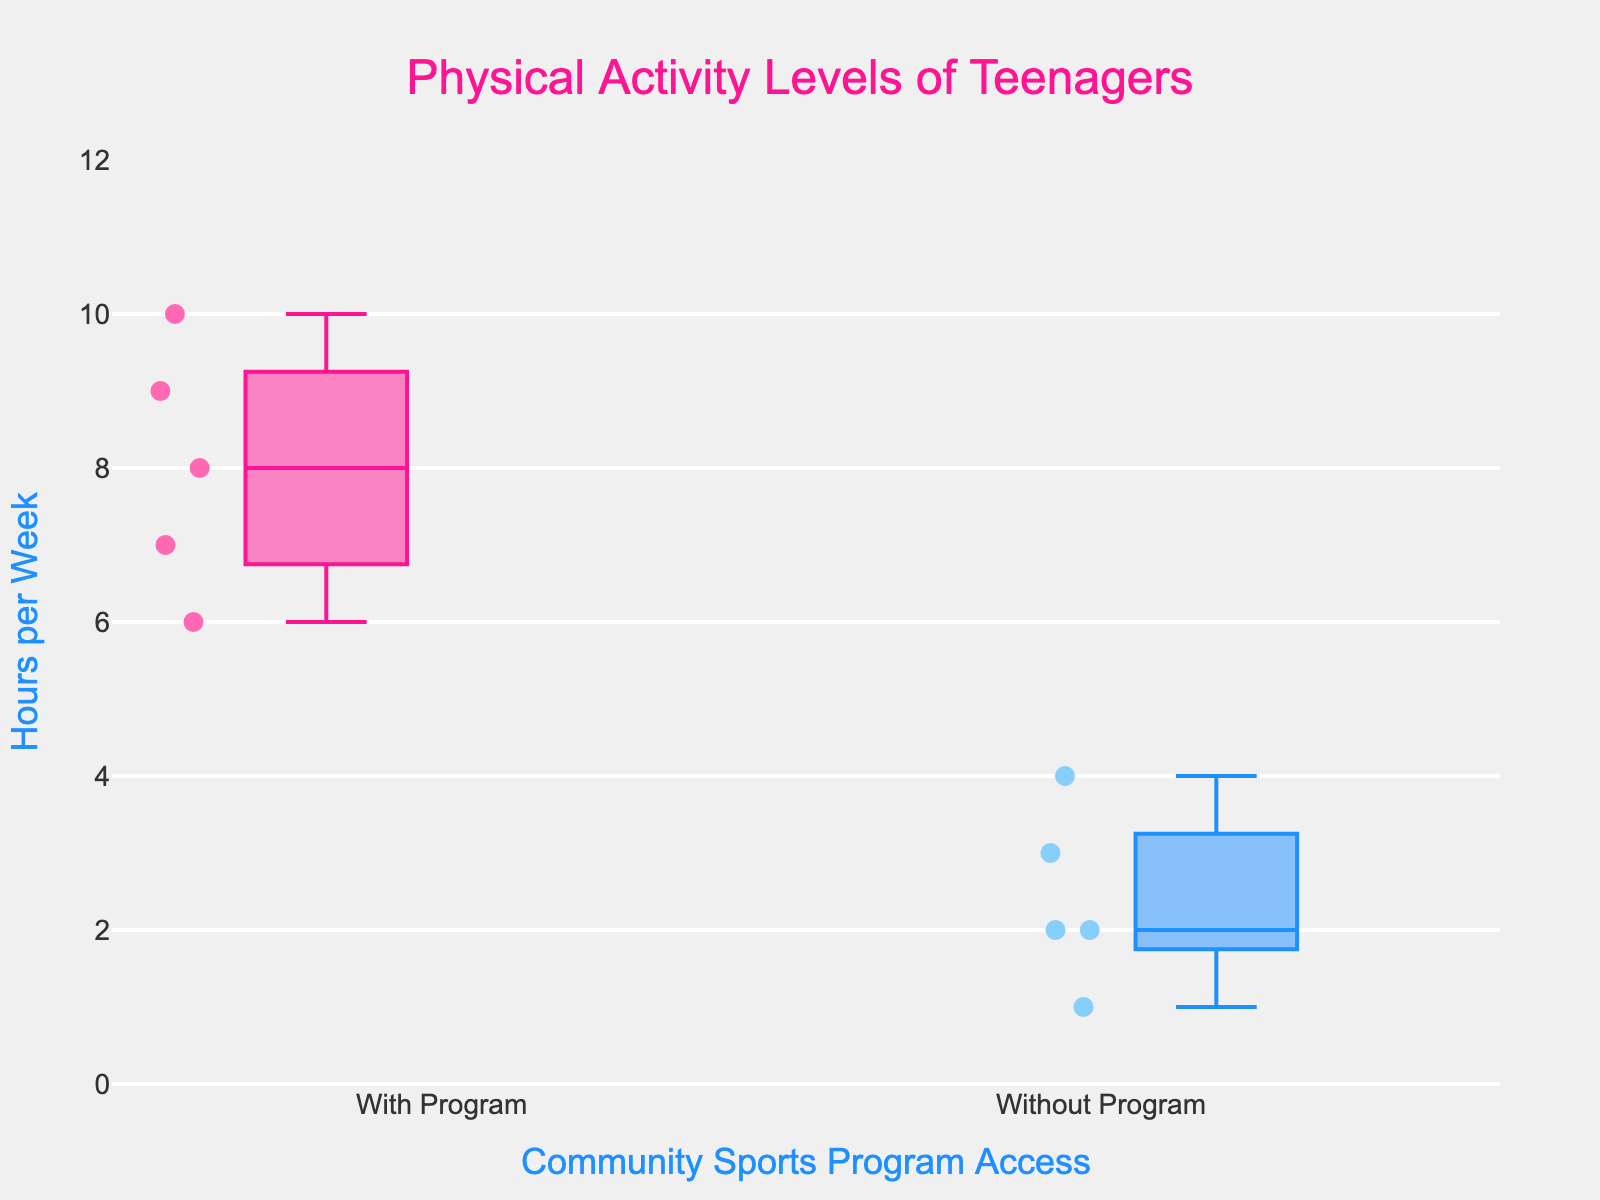How many teenagers were surveyed in the group with access to the community sports program? Count the number of data points in the "With Program" group; there are 5 data points: Alice, Bob, Charlie, Diana, and Eddie.
Answer: 5 What's the median number of physical activity hours per week for teenagers without access to the community sports program? Order the data points in the "Without Program" group (1, 2, 2, 3, 4) and find the middle value. Here, the median is the third data point, which is 2.
Answer: 2 Which group has the higher median number of physical activity hours per week? Find the median for both groups: "With Program" group has values (6, 7, 8, 9, 10), and the median is 8. The "Without Program" group has values (1, 2, 2, 3, 4), and the median is 2. So, the "With Program" group has a higher median.
Answer: With Program What is the range of physical activity hours per week for teenagers with access to the community sports program? Identify the minimum and maximum values in the "With Program" group (6 and 10, respectively) and calculate the difference (10 - 6).
Answer: 4 What is the interquartile range (IQR) of physical activity hours per week for teenagers without access to the community sports program? Find the first quartile (Q1) and third quartile (Q3) values for the "Without Program" group. Ordered data points: 1, 2, 2, 3, 4. Q1 = 2 (second value), Q3 = 3 (fourth value). IQR = Q3 - Q1 = 3 - 2.
Answer: 1 Compare the variability of physical activity hours per week between the two groups. Which group has more variability? Compare the IQR or range for both groups. "With Program" group IQR = 9 - 7 = 2, range = 4; "Without Program" group IQR = 3 - 2 = 1, range = 3. The "With Program" group has more variability.
Answer: With Program Are there any outliers in the physical activity levels of teenagers in either group? Check the box plots for any individual points that fall outside the whiskers, indicating outliers. Neither box plot shows points outside the whiskers, so there are no outliers.
Answer: No What is the mode of the physical activity hours per week for teenagers without access to the community sports program? Identify the most frequently occurring value in the "Without Program" group (1, 2, 2, 3, 4). The mode is 2, as it appears most frequently.
Answer: 2 